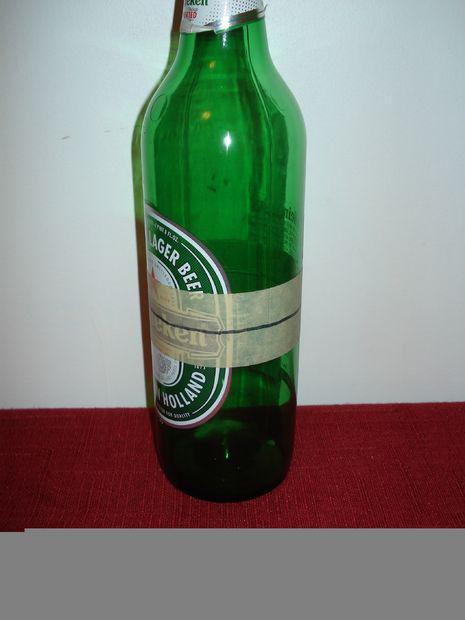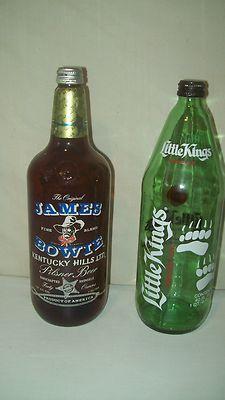The first image is the image on the left, the second image is the image on the right. Assess this claim about the two images: "The image on the right shows two green glass bottles". Correct or not? Answer yes or no. No. The first image is the image on the left, the second image is the image on the right. For the images shown, is this caption "An image contains exactly two bottles, both green and the same height." true? Answer yes or no. No. 